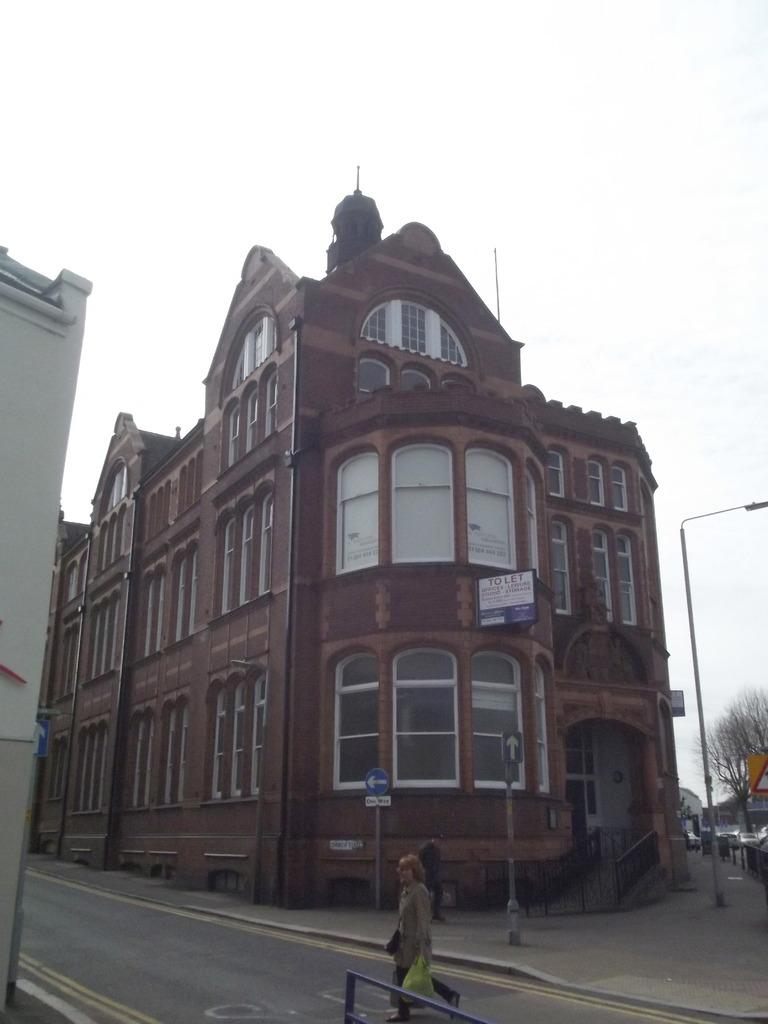What is the main subject in the foreground of the image? There is a person walking on the road in the foreground of the image. What is the person holding in the image? The person is holding a cover. What can be seen in the background of the image? There are buildings, a pole, a sign board, a tree, and the sky visible in the background of the image. What type of pickle is the monkey eating on the tree in the image? There is no monkey or pickle present in the image. Can you hear the thunder in the background of the image? The image is a still picture, so there is no sound or thunder present. 